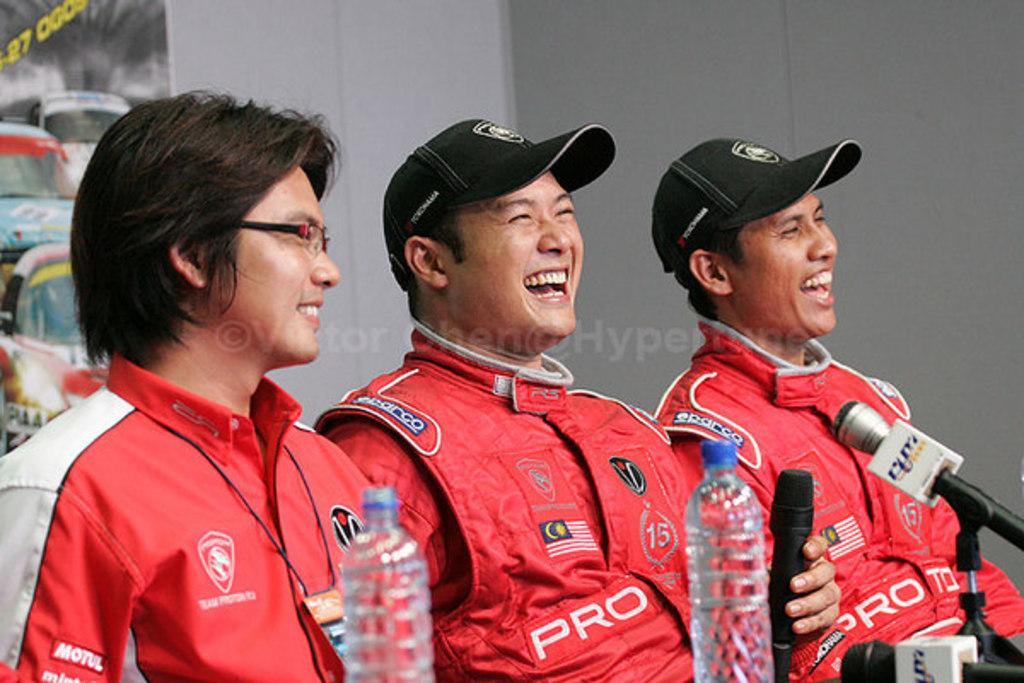Describe this image in one or two sentences. In the image there are three men, three of them are laughing they are wearing red costume and there are three mics in front of them and on the left side there are two bottles. In the background there is a banner and beside the banner there is a wall. 